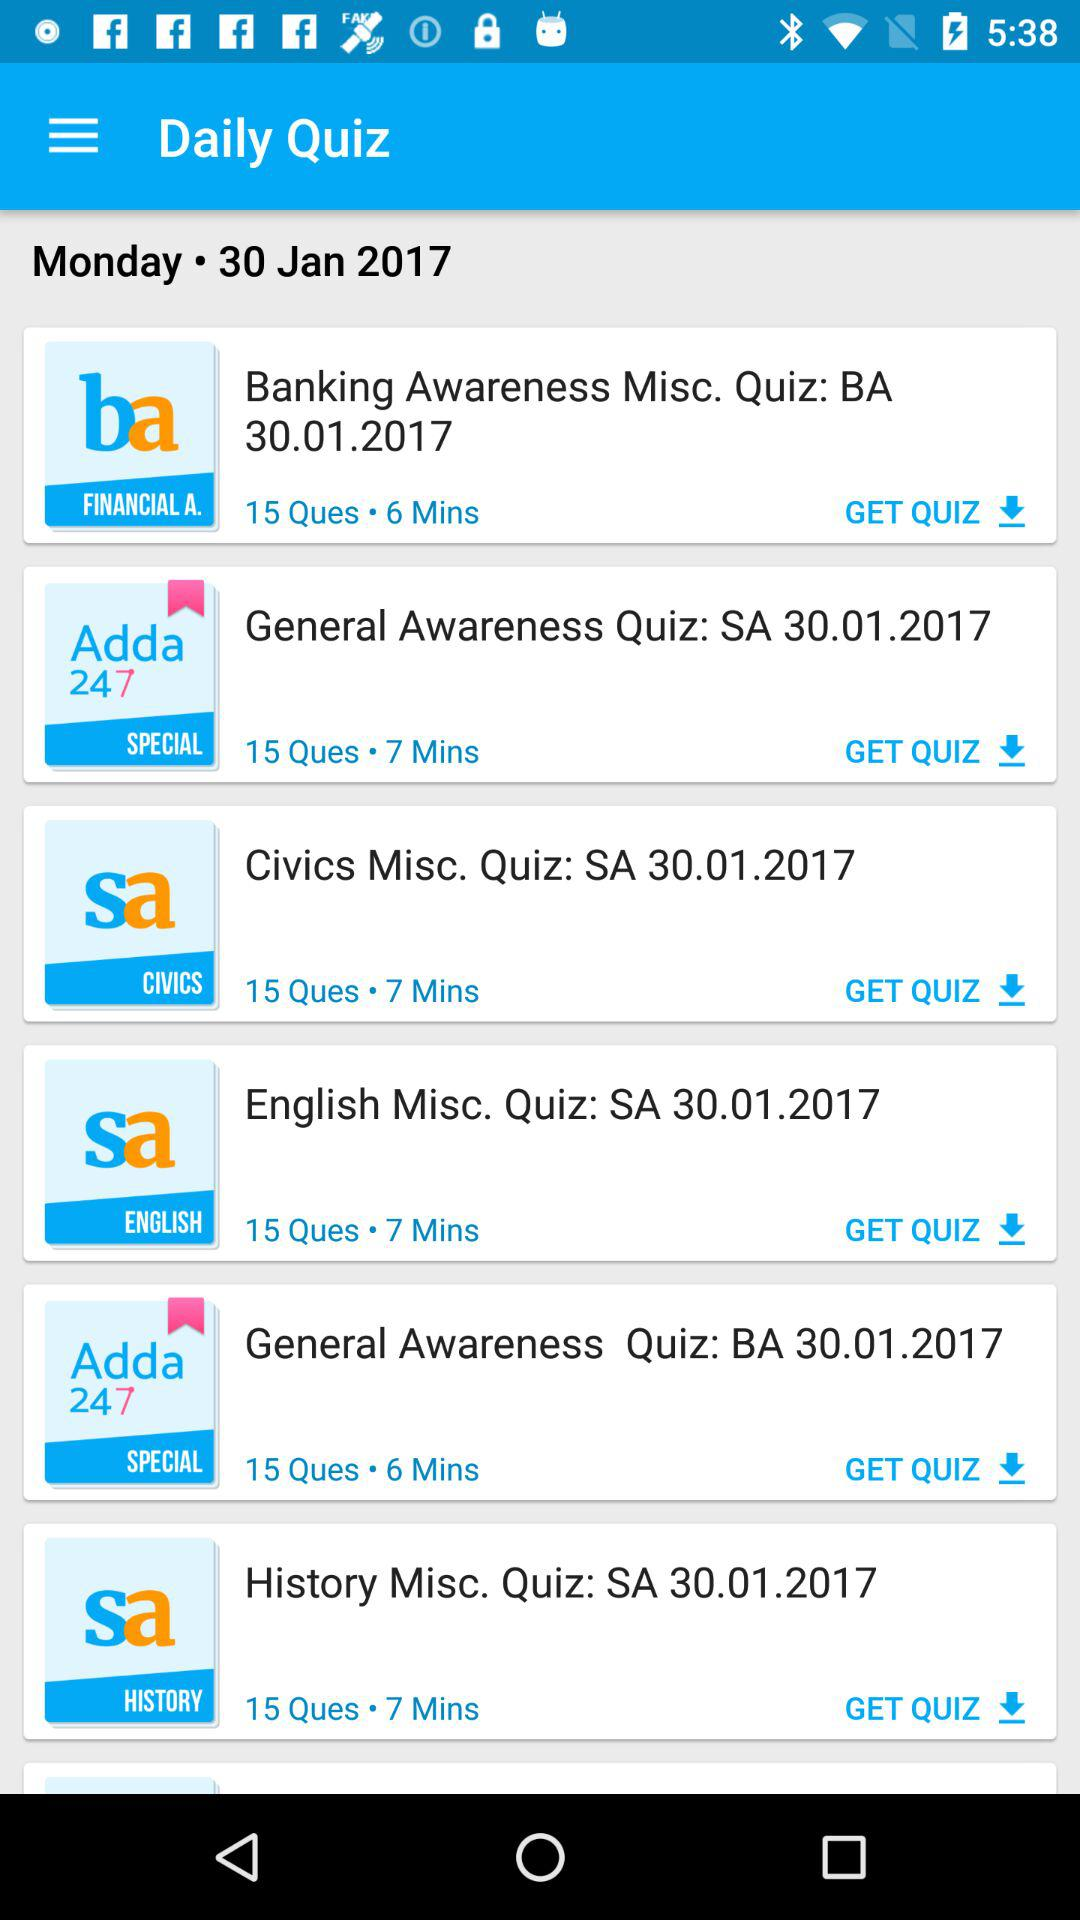What is the duration of the "Banking Awareness Misc. Quiz"? The duration of the "Banking Awareness Misc. Quiz" is 6 minutes. 